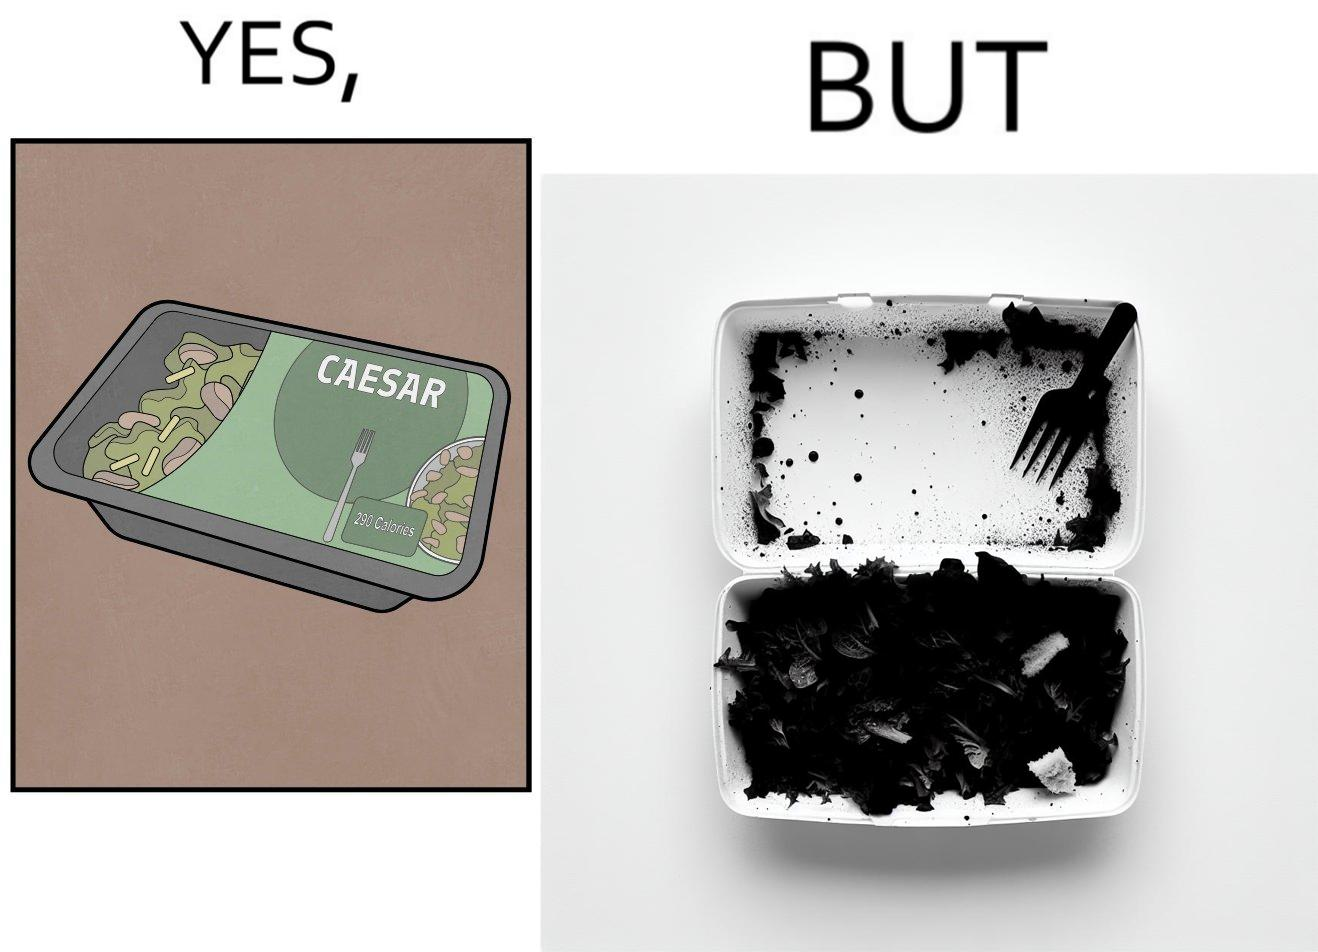Describe the satirical element in this image. Image is funny because the box of salad was marketed in a way that showed a lot more salad content than was really present inside it. 